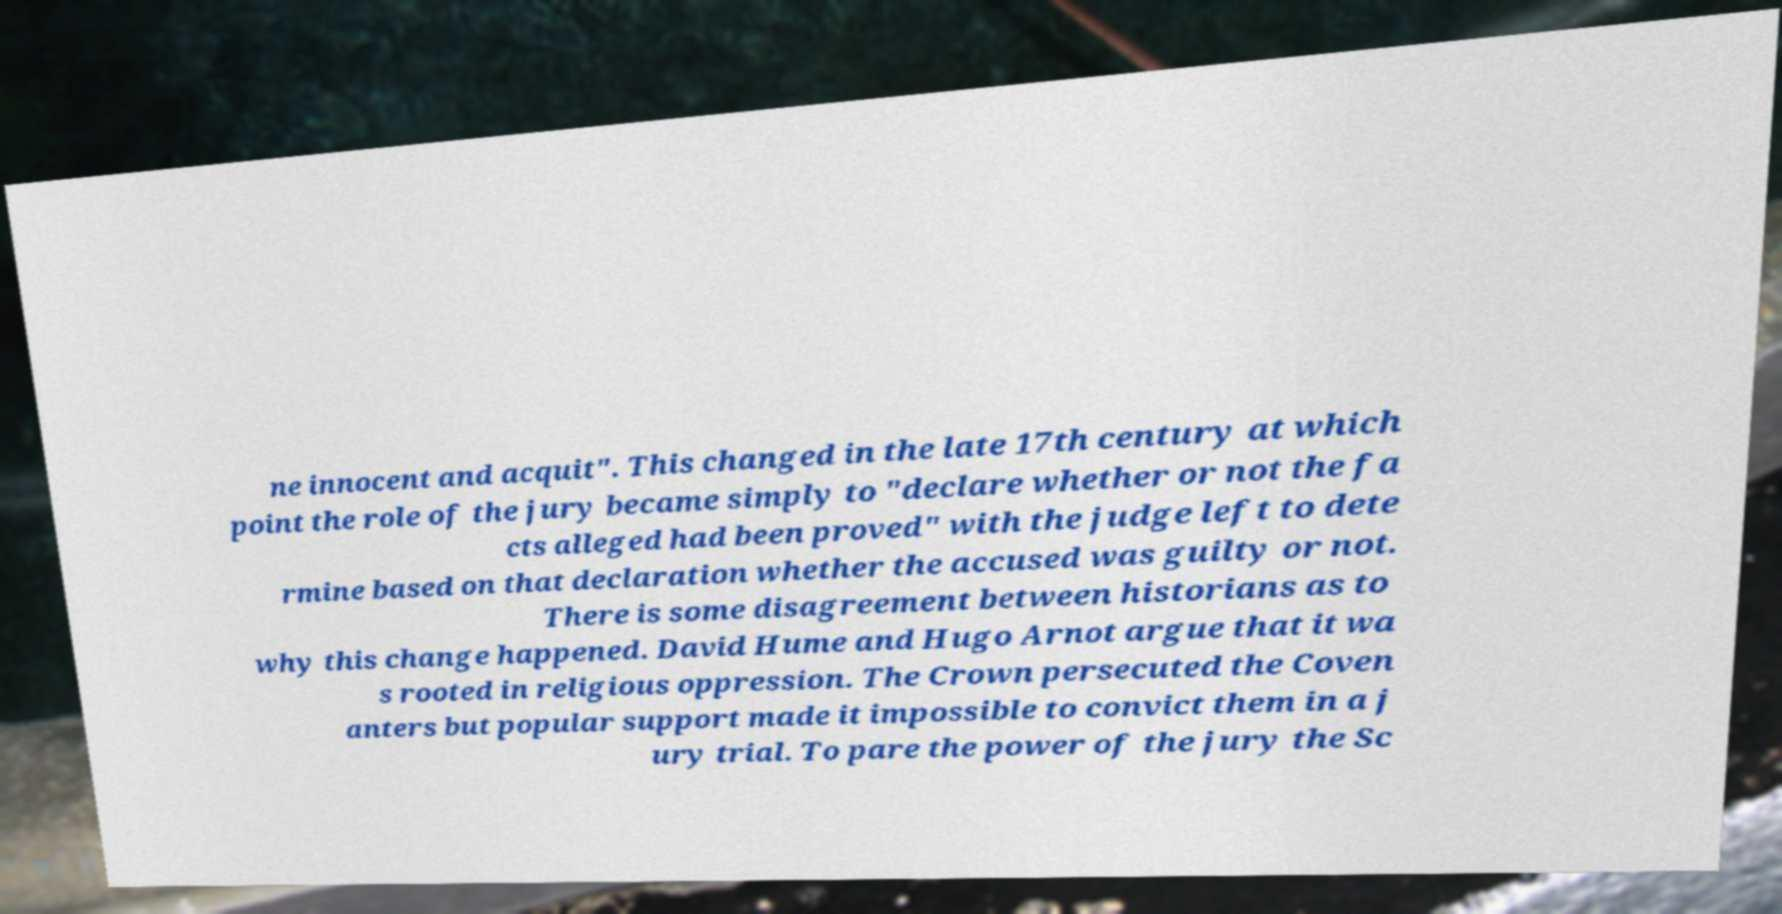Can you accurately transcribe the text from the provided image for me? ne innocent and acquit". This changed in the late 17th century at which point the role of the jury became simply to "declare whether or not the fa cts alleged had been proved" with the judge left to dete rmine based on that declaration whether the accused was guilty or not. There is some disagreement between historians as to why this change happened. David Hume and Hugo Arnot argue that it wa s rooted in religious oppression. The Crown persecuted the Coven anters but popular support made it impossible to convict them in a j ury trial. To pare the power of the jury the Sc 